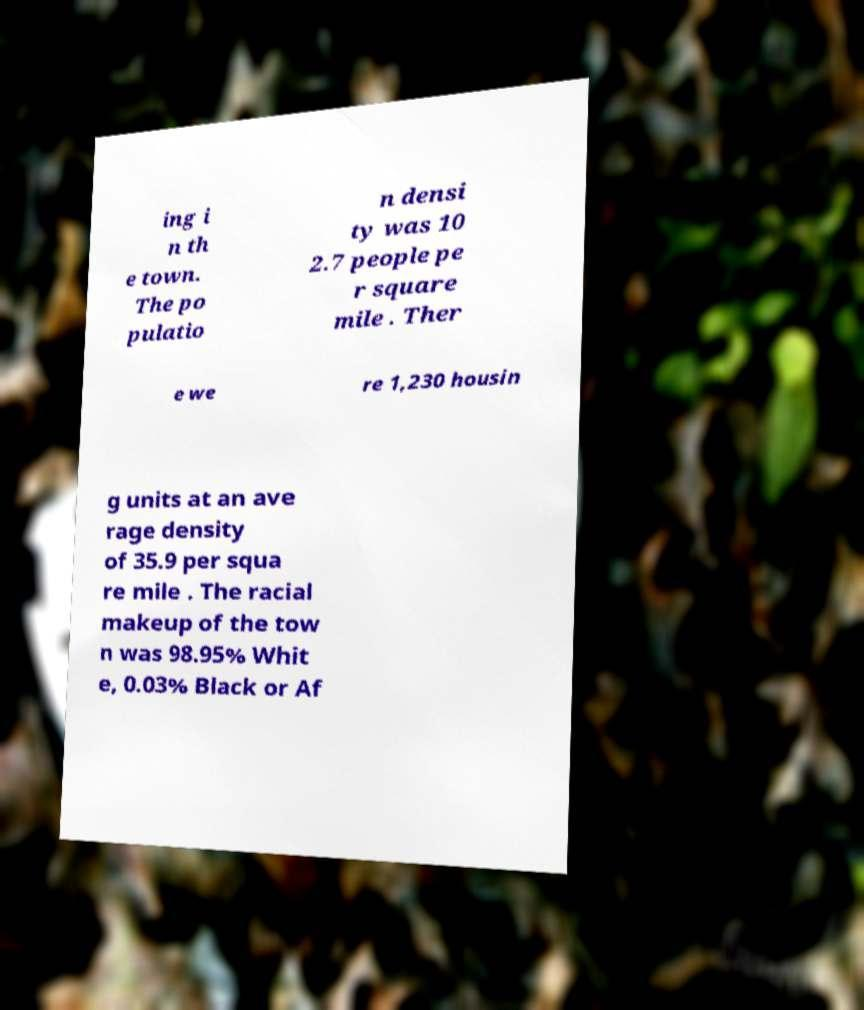There's text embedded in this image that I need extracted. Can you transcribe it verbatim? ing i n th e town. The po pulatio n densi ty was 10 2.7 people pe r square mile . Ther e we re 1,230 housin g units at an ave rage density of 35.9 per squa re mile . The racial makeup of the tow n was 98.95% Whit e, 0.03% Black or Af 